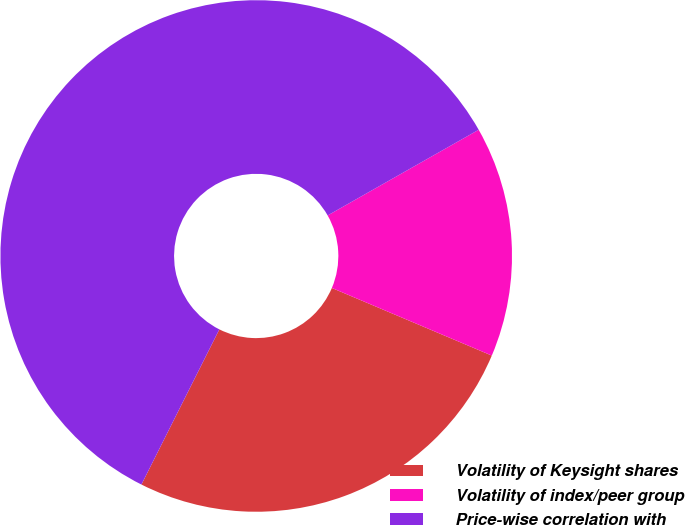Convert chart to OTSL. <chart><loc_0><loc_0><loc_500><loc_500><pie_chart><fcel>Volatility of Keysight shares<fcel>Volatility of index/peer group<fcel>Price-wise correlation with<nl><fcel>26.04%<fcel>14.58%<fcel>59.38%<nl></chart> 